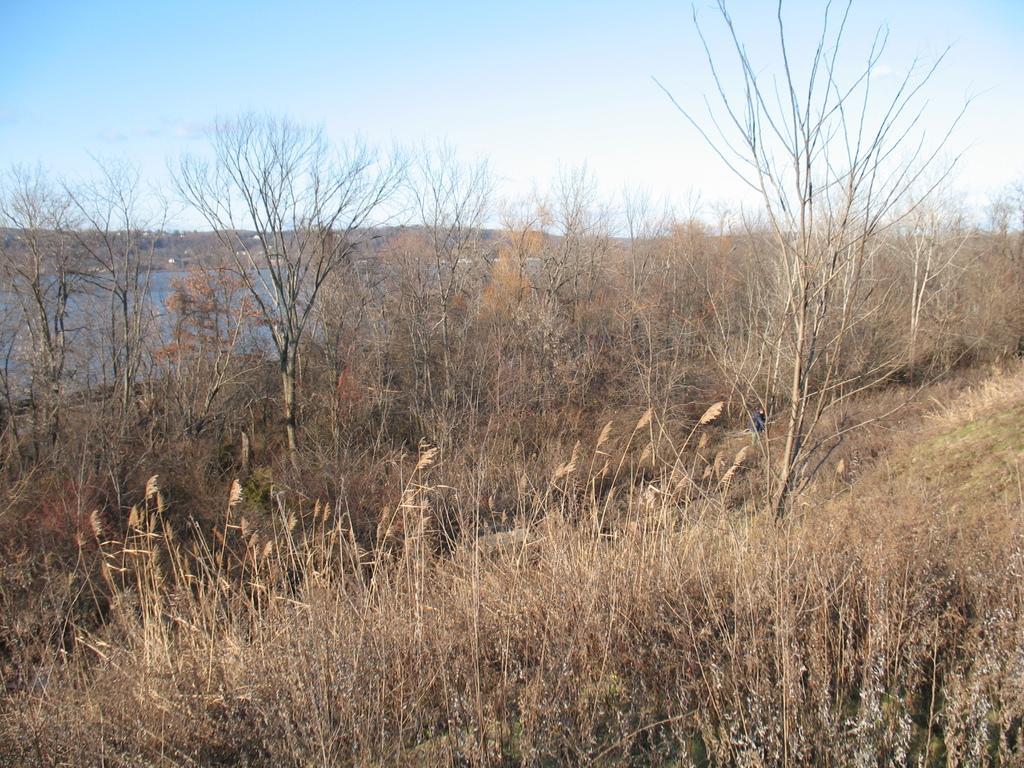Please provide a concise description of this image. In this image we can see the dried grass. And we can see the branches of dried trees and the water. At the top we can see the sky. 